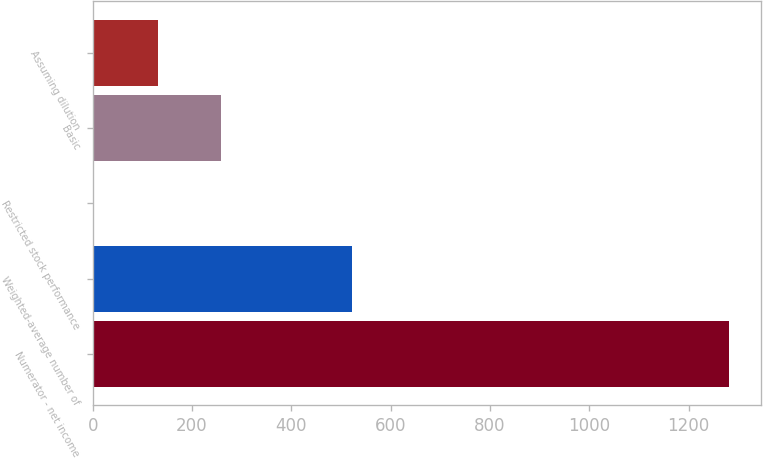<chart> <loc_0><loc_0><loc_500><loc_500><bar_chart><fcel>Numerator - net income<fcel>Weighted-average number of<fcel>Restricted stock performance<fcel>Basic<fcel>Assuming dilution<nl><fcel>1281<fcel>521.3<fcel>3<fcel>258.6<fcel>130.8<nl></chart> 